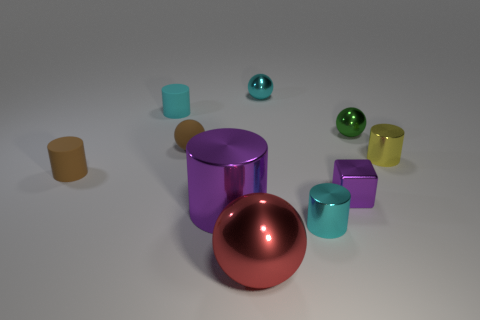Subtract all cyan cylinders. How many were subtracted if there are1cyan cylinders left? 1 Subtract all big metal spheres. How many spheres are left? 3 Subtract all yellow blocks. How many cyan cylinders are left? 2 Subtract all green spheres. How many spheres are left? 3 Subtract 3 cylinders. How many cylinders are left? 2 Subtract all spheres. How many objects are left? 6 Subtract all rubber objects. Subtract all small cyan balls. How many objects are left? 6 Add 8 large purple things. How many large purple things are left? 9 Add 4 green metallic balls. How many green metallic balls exist? 5 Subtract 0 gray blocks. How many objects are left? 10 